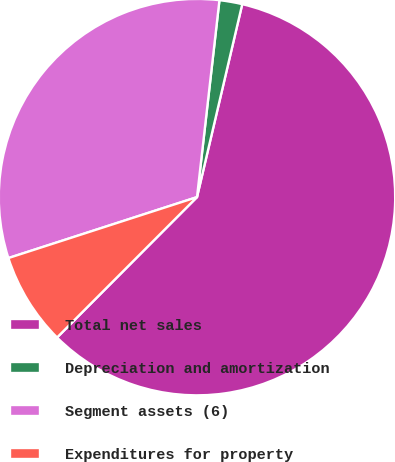<chart> <loc_0><loc_0><loc_500><loc_500><pie_chart><fcel>Total net sales<fcel>Depreciation and amortization<fcel>Segment assets (6)<fcel>Expenditures for property<nl><fcel>58.81%<fcel>1.86%<fcel>31.78%<fcel>7.55%<nl></chart> 